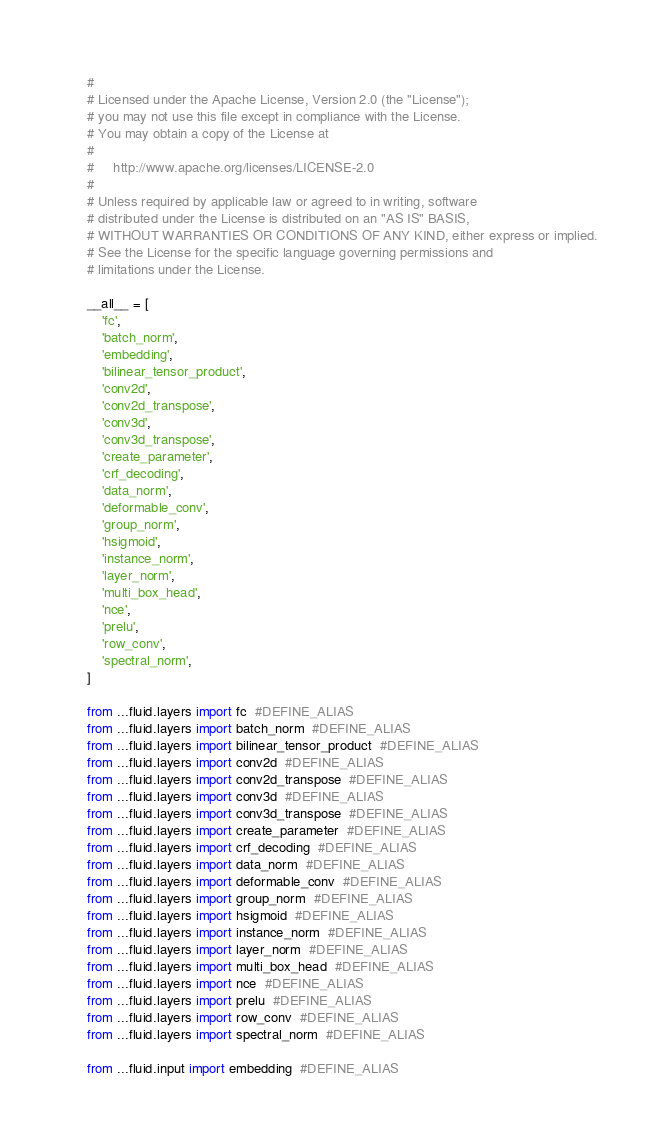<code> <loc_0><loc_0><loc_500><loc_500><_Python_>#
# Licensed under the Apache License, Version 2.0 (the "License");
# you may not use this file except in compliance with the License.
# You may obtain a copy of the License at
#
#     http://www.apache.org/licenses/LICENSE-2.0
#
# Unless required by applicable law or agreed to in writing, software
# distributed under the License is distributed on an "AS IS" BASIS,
# WITHOUT WARRANTIES OR CONDITIONS OF ANY KIND, either express or implied.
# See the License for the specific language governing permissions and
# limitations under the License.

__all__ = [
    'fc',
    'batch_norm',
    'embedding',
    'bilinear_tensor_product',
    'conv2d',
    'conv2d_transpose',
    'conv3d',
    'conv3d_transpose',
    'create_parameter',
    'crf_decoding',
    'data_norm',
    'deformable_conv',
    'group_norm',
    'hsigmoid',
    'instance_norm',
    'layer_norm',
    'multi_box_head',
    'nce',
    'prelu',
    'row_conv',
    'spectral_norm',
]

from ...fluid.layers import fc  #DEFINE_ALIAS
from ...fluid.layers import batch_norm  #DEFINE_ALIAS
from ...fluid.layers import bilinear_tensor_product  #DEFINE_ALIAS
from ...fluid.layers import conv2d  #DEFINE_ALIAS
from ...fluid.layers import conv2d_transpose  #DEFINE_ALIAS
from ...fluid.layers import conv3d  #DEFINE_ALIAS
from ...fluid.layers import conv3d_transpose  #DEFINE_ALIAS
from ...fluid.layers import create_parameter  #DEFINE_ALIAS
from ...fluid.layers import crf_decoding  #DEFINE_ALIAS
from ...fluid.layers import data_norm  #DEFINE_ALIAS
from ...fluid.layers import deformable_conv  #DEFINE_ALIAS
from ...fluid.layers import group_norm  #DEFINE_ALIAS
from ...fluid.layers import hsigmoid  #DEFINE_ALIAS
from ...fluid.layers import instance_norm  #DEFINE_ALIAS
from ...fluid.layers import layer_norm  #DEFINE_ALIAS
from ...fluid.layers import multi_box_head  #DEFINE_ALIAS
from ...fluid.layers import nce  #DEFINE_ALIAS
from ...fluid.layers import prelu  #DEFINE_ALIAS
from ...fluid.layers import row_conv  #DEFINE_ALIAS
from ...fluid.layers import spectral_norm  #DEFINE_ALIAS

from ...fluid.input import embedding  #DEFINE_ALIAS
</code> 